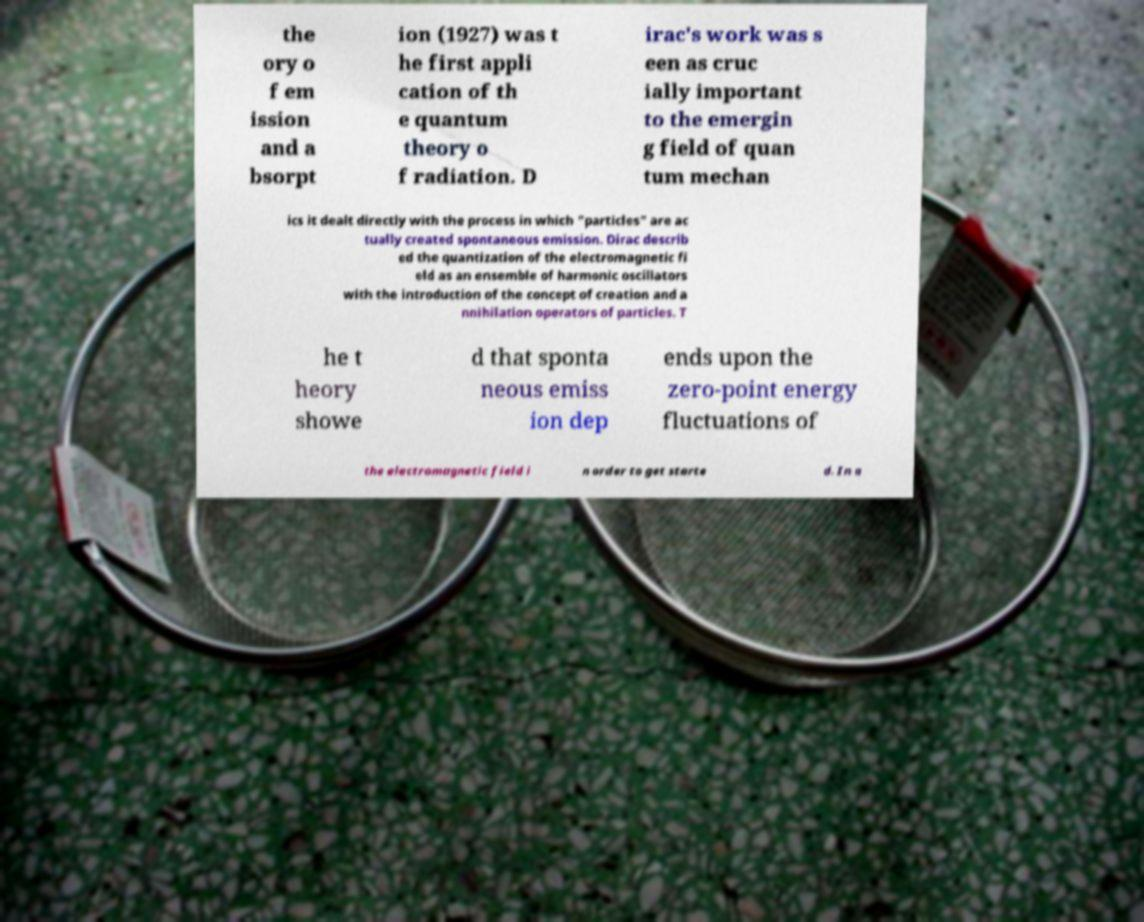I need the written content from this picture converted into text. Can you do that? the ory o f em ission and a bsorpt ion (1927) was t he first appli cation of th e quantum theory o f radiation. D irac's work was s een as cruc ially important to the emergin g field of quan tum mechan ics it dealt directly with the process in which "particles" are ac tually created spontaneous emission. Dirac describ ed the quantization of the electromagnetic fi eld as an ensemble of harmonic oscillators with the introduction of the concept of creation and a nnihilation operators of particles. T he t heory showe d that sponta neous emiss ion dep ends upon the zero-point energy fluctuations of the electromagnetic field i n order to get starte d. In a 